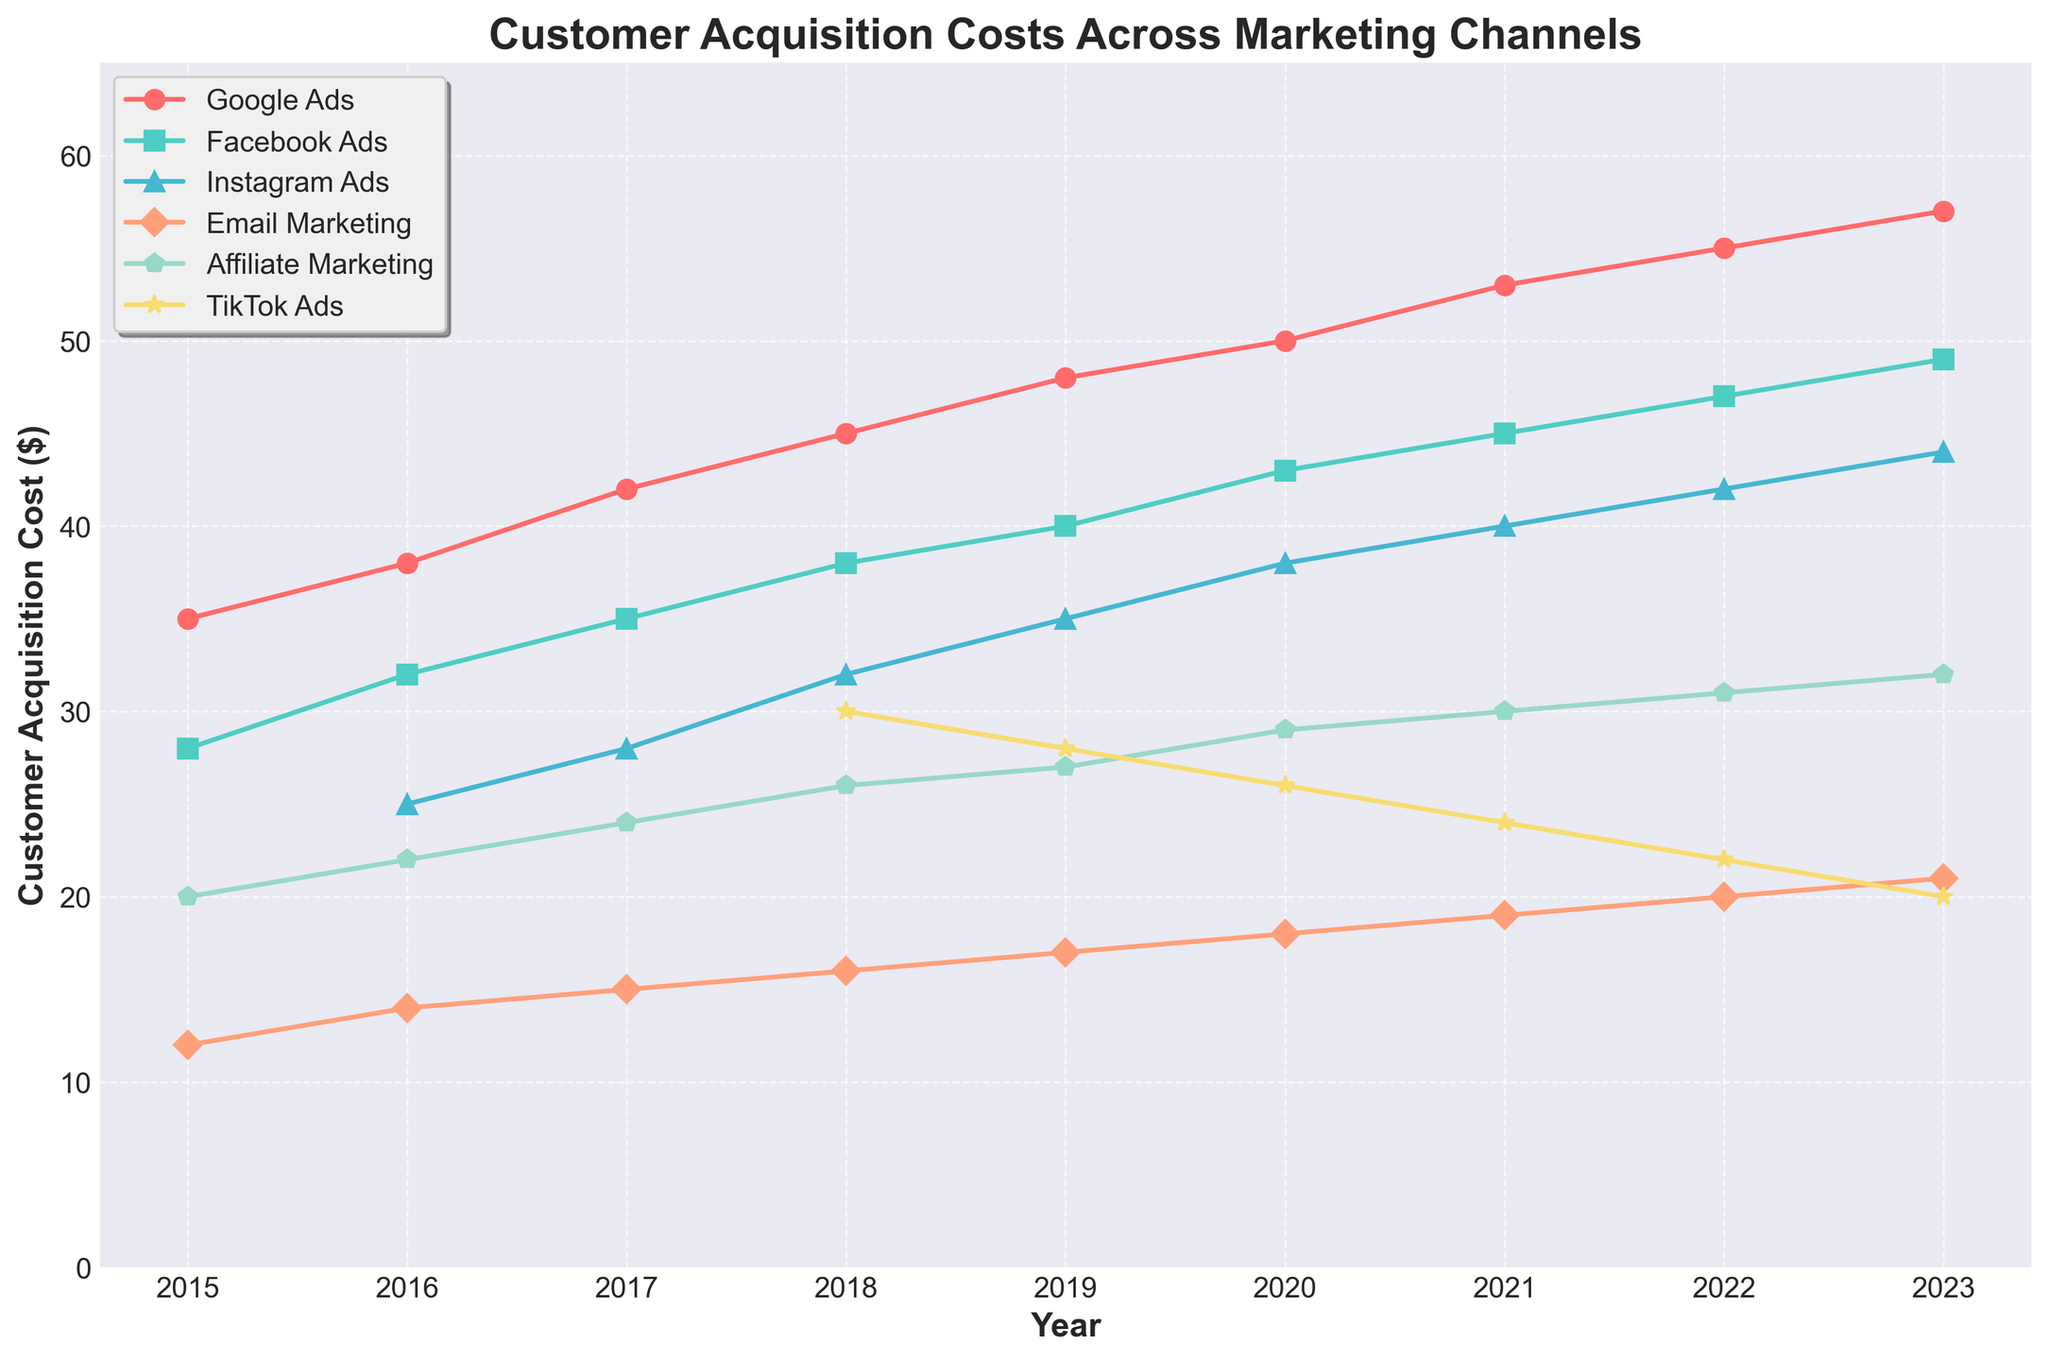Which marketing channel had the highest customer acquisition cost in 2023? Look for the highest point among all lines at the 2023 mark. The line labeled "Google Ads" has the highest value.
Answer: Google Ads What's the difference in customer acquisition cost between Google Ads and TikTok Ads in 2023? Subtract the customer acquisition cost of TikTok Ads from that of Google Ads for the year 2023. For Google Ads, it is $57; for TikTok Ads, it is $20. So, the difference is 57 - 20 = 37.
Answer: 37 Which marketing channel showed the most significant increase in customer acquisition cost from 2015 to 2023? Calculate the difference between the 2023 and 2015 values for each channel. TickTok Ads and Instagram Ads did not exist in 2015. Google Ads increased from 35 to 57 (22), Facebook Ads from 28 to 49 (21), Instagram Ads from 25 to 44 (19), Email Marketing from 12 to 21 (9), Affiliate Marketing from 20 to 32 (12). Google Ads has the largest increase of 22.
Answer: Google Ads What was the average customer acquisition cost for Facebook Ads over the years 2016 to 2020? Add the values for Facebook Ads from 2016 to 2020: 32 + 35 + 38 + 40 + 43 = 188. Then divide by the number of years, which is 5. The average is 188 / 5 = 37.6.
Answer: 37.6 How does the customer acquisition cost trend of Email Marketing compare to Affiliate Marketing from 2015 to 2023? Observe the slopes of the lines representing Email Marketing and Affiliate Marketing over the years. While both lines show an increasing trend, Email Marketing has a consistent slight increase, whereas Affiliate Marketing shows a steeper and more pronounced increase.
Answer: Affiliate Marketing has a steeper increase In what year did Instagram Ads first appear, and what was the initial customer acquisition cost? Instagram Ads first appear in the year 2016. The initial customer acquisition cost for Instagram Ads in that year is 25.
Answer: 2016, 25 Which channel has the lowest customer acquisition cost in 2018, and what is the value? Find the lowest point among all lines for the year 2018. Email Marketing has the lowest value at 16.
Answer: Email Marketing, 16 What's the average customer acquisition cost across all channels (that have data) for the year 2020? Sum the 2020 costs for each channel that has data: 50 + 43 + 38 + 18 + 29 + 26 = 204. Divide by the number of channels, which is 6. The average is 204 / 6 = 34.
Answer: 34 